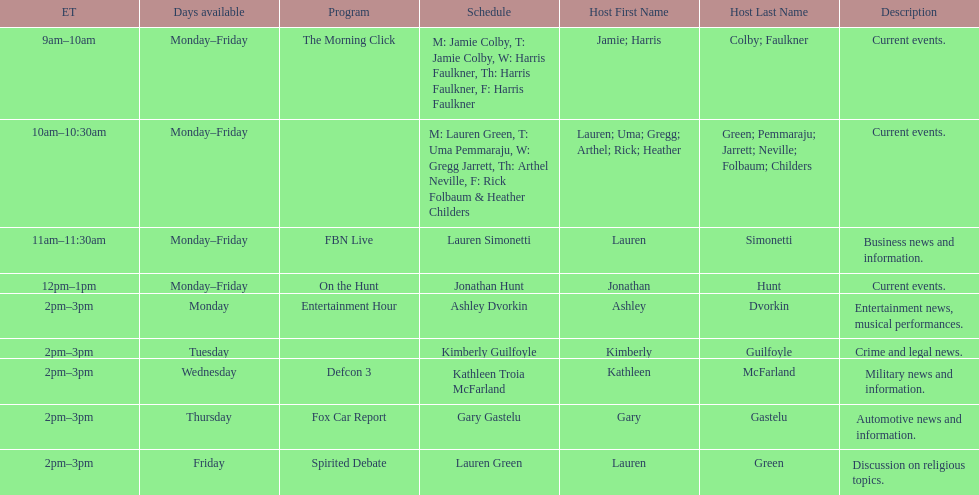How long does on the hunt run? 1 hour. 